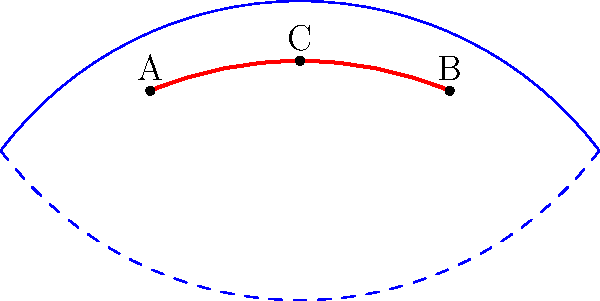Consider a Möbius strip represented by the blue curves in the diagram. A closed loop (shown in red) is drawn on the surface of the strip, starting and ending at point A. Given that the geodesic distance between points A and B is 5 units, B and C is 3 units, and C and A is 4 units, calculate the perimeter of the closed loop. How does this result relate to the non-orientability of the Möbius strip? To solve this problem, we need to consider the unique properties of a Möbius strip and how they affect measurements on its surface:

1) First, let's calculate the apparent perimeter of the loop:
   $AB + BC + CA = 5 + 3 + 4 = 12$ units

2) However, the Möbius strip is a non-orientable surface. This means that as we traverse the loop, we may pass through the "twist" in the strip.

3) The key insight is that the distance AB (5 units) actually represents the full journey around the Möbius strip, returning to the starting point but on the "opposite" side.

4) The segments BC and CA (3 and 4 units) together represent the path that crosses from one "side" of the strip to the other.

5) Therefore, the actual perimeter of the closed loop is just the length of AB:
   Perimeter = 5 units

6) This result relates to the non-orientability of the Möbius strip in that it demonstrates how a path that appears to cover the entire "surface" of the strip can actually return to its starting point in less distance than expected. The concepts of "inside" and "outside" or "top" and "bottom" are not well-defined on a Möbius strip.

7) In terms of differential geometry, this problem illustrates how the global topology of a manifold (in this case, the Möbius strip) can affect local measurements and paths, demonstrating the deep connection between geometry and topology in physics.
Answer: 5 units 